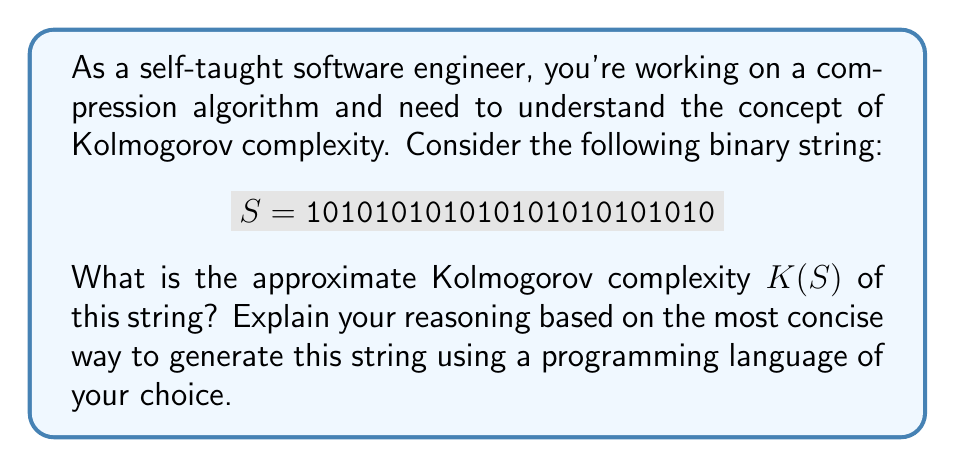Solve this math problem. Let's approach this step-by-step:

1) The Kolmogorov complexity $K(S)$ of a string $S$ is the length of the shortest program that produces $S$ as its output.

2) Looking at the string $S = 101010101010101010101010$, we can see a clear pattern: it's the repetition of "10" twelve times.

3) In a practical programming scenario, we can generate this string using a simple loop. For example, in Python:

   ```python
   print("10" * 12)
   ```

4) The core components of this program are:
   - The string "10"
   - The number 12
   - The repetition operation (*)
   - The print function

5) To estimate the Kolmogorov complexity, we need to consider the length of the description of this program in a suitable language.

6) A rough estimate might be:
   - 2 bits for "10"
   - About 4 bits to encode the number 12 (as it's less than 16, which requires 4 bits in binary)
   - A few bits for the repetition operation and print function (let's estimate this as 8 bits)

7) Therefore, an approximate lower bound for $K(S)$ would be:

   $$K(S) \approx 2 + 4 + 8 = 14 \text{ bits}$$

8) This is significantly less than the 24 bits required to represent the string directly, indicating that the string has a relatively low Kolmogorov complexity compared to its length.
Answer: $K(S) \approx 14 \text{ bits}$ 